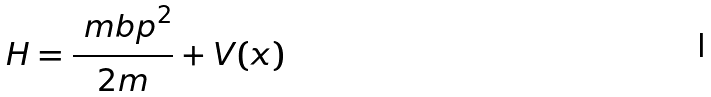Convert formula to latex. <formula><loc_0><loc_0><loc_500><loc_500>H = \frac { { \ m b p } ^ { 2 } } { 2 m } + V ( { x } )</formula> 